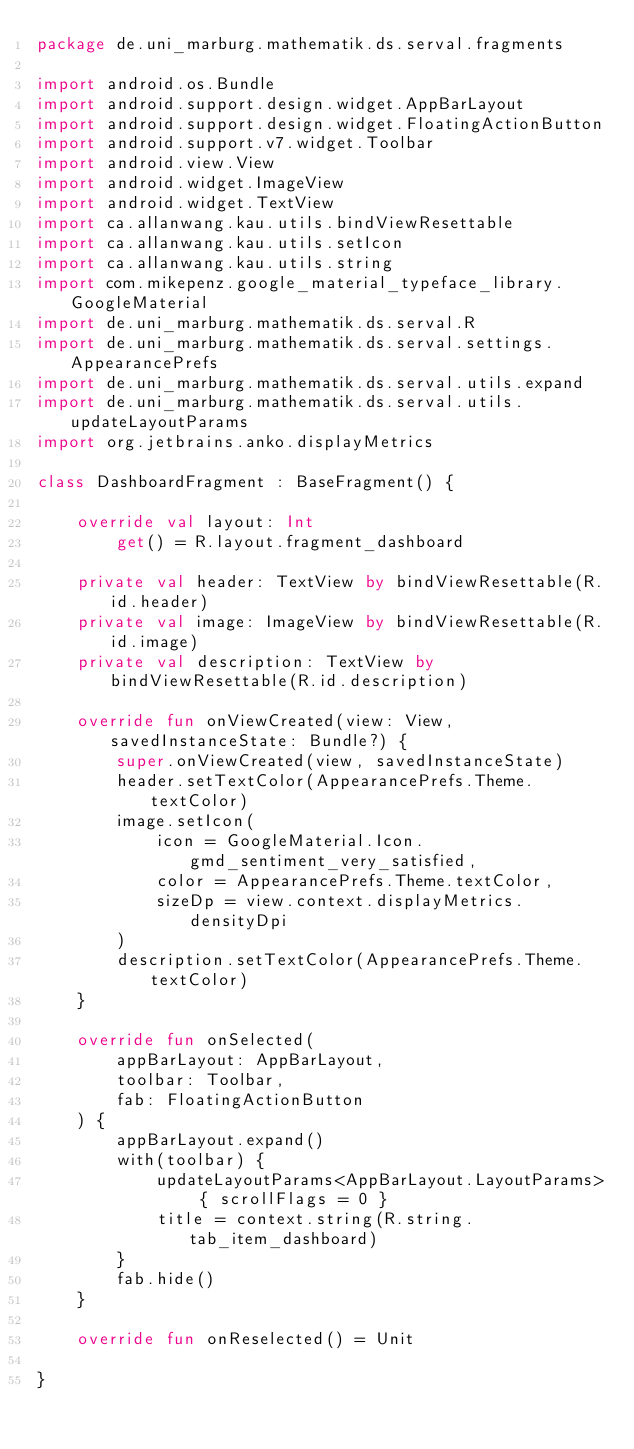Convert code to text. <code><loc_0><loc_0><loc_500><loc_500><_Kotlin_>package de.uni_marburg.mathematik.ds.serval.fragments

import android.os.Bundle
import android.support.design.widget.AppBarLayout
import android.support.design.widget.FloatingActionButton
import android.support.v7.widget.Toolbar
import android.view.View
import android.widget.ImageView
import android.widget.TextView
import ca.allanwang.kau.utils.bindViewResettable
import ca.allanwang.kau.utils.setIcon
import ca.allanwang.kau.utils.string
import com.mikepenz.google_material_typeface_library.GoogleMaterial
import de.uni_marburg.mathematik.ds.serval.R
import de.uni_marburg.mathematik.ds.serval.settings.AppearancePrefs
import de.uni_marburg.mathematik.ds.serval.utils.expand
import de.uni_marburg.mathematik.ds.serval.utils.updateLayoutParams
import org.jetbrains.anko.displayMetrics

class DashboardFragment : BaseFragment() {

    override val layout: Int
        get() = R.layout.fragment_dashboard

    private val header: TextView by bindViewResettable(R.id.header)
    private val image: ImageView by bindViewResettable(R.id.image)
    private val description: TextView by bindViewResettable(R.id.description)

    override fun onViewCreated(view: View, savedInstanceState: Bundle?) {
        super.onViewCreated(view, savedInstanceState)
        header.setTextColor(AppearancePrefs.Theme.textColor)
        image.setIcon(
            icon = GoogleMaterial.Icon.gmd_sentiment_very_satisfied,
            color = AppearancePrefs.Theme.textColor,
            sizeDp = view.context.displayMetrics.densityDpi
        )
        description.setTextColor(AppearancePrefs.Theme.textColor)
    }

    override fun onSelected(
        appBarLayout: AppBarLayout,
        toolbar: Toolbar,
        fab: FloatingActionButton
    ) {
        appBarLayout.expand()
        with(toolbar) {
            updateLayoutParams<AppBarLayout.LayoutParams> { scrollFlags = 0 }
            title = context.string(R.string.tab_item_dashboard)
        }
        fab.hide()
    }

    override fun onReselected() = Unit

}
</code> 